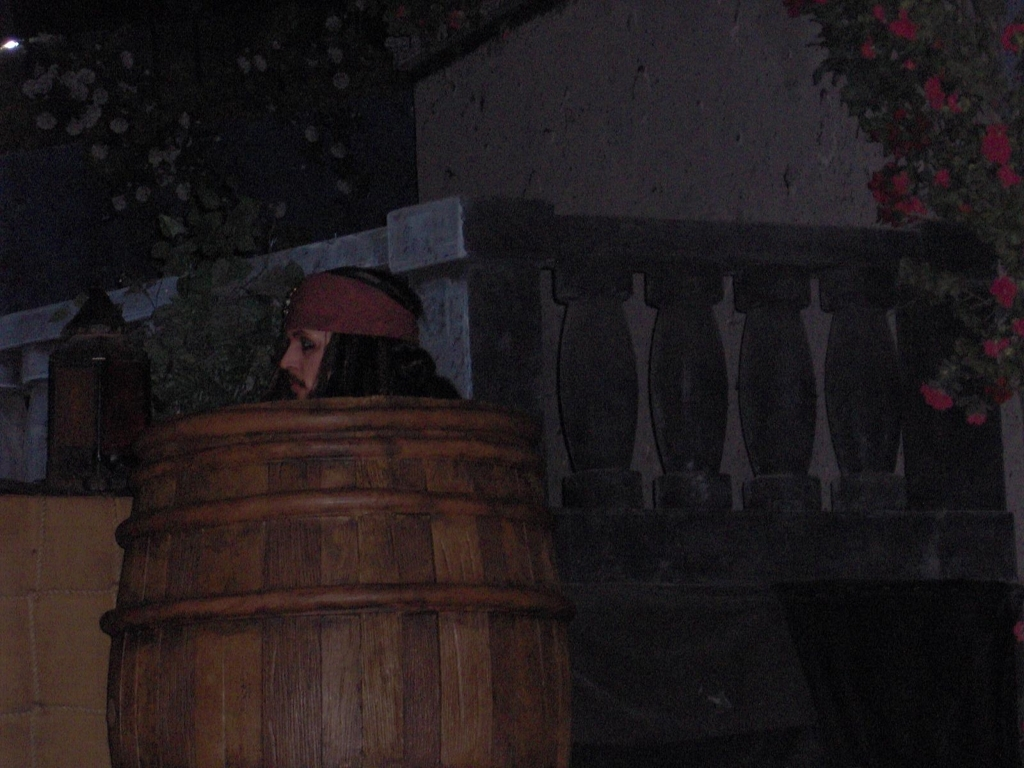What time of day does this scene seem to be, and what clued you in? The scene appears to take place at night, indicated by the subdued lighting; the shadows suggest the absence of direct sunlight. Can you imagine a story that might be happening here? Certainly. The image could depict a scene from a story where the character is hiding or waiting for someone in a rustic, possibly medieval setting, perhaps plotting a clandestine meeting or evading pursuit. 